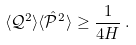<formula> <loc_0><loc_0><loc_500><loc_500>\langle \mathcal { Q } ^ { 2 } \rangle \langle \hat { \mathcal { P } } ^ { 2 } \rangle \geq \frac { 1 } { 4 H } \, .</formula> 